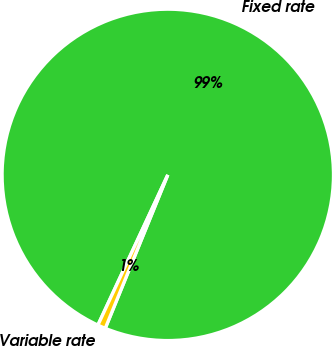Convert chart to OTSL. <chart><loc_0><loc_0><loc_500><loc_500><pie_chart><fcel>Fixed rate<fcel>Variable rate<nl><fcel>99.23%<fcel>0.77%<nl></chart> 